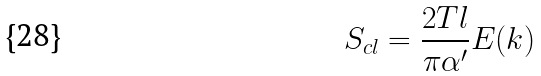Convert formula to latex. <formula><loc_0><loc_0><loc_500><loc_500>S _ { c l } = \frac { 2 T l } { \pi \alpha ^ { \prime } } E ( k )</formula> 